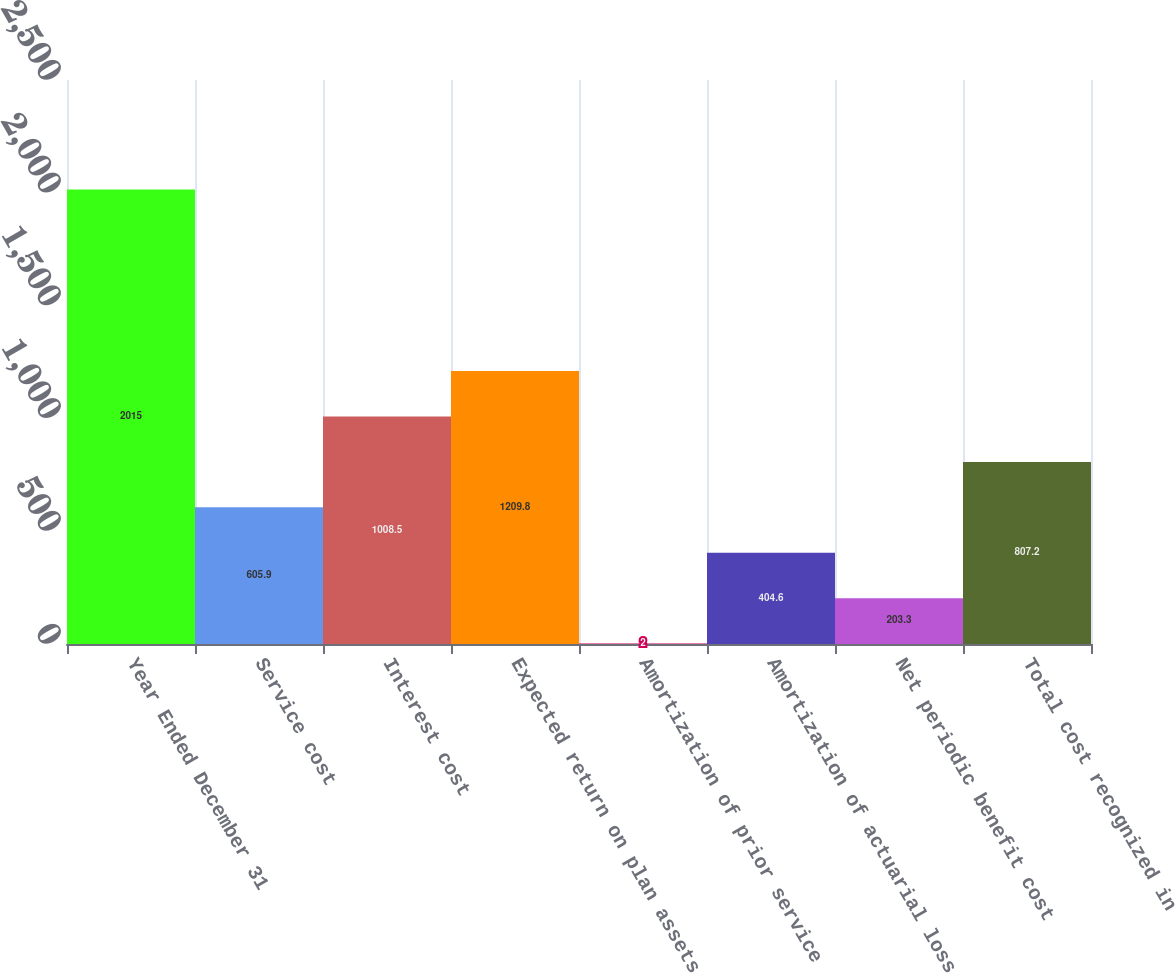<chart> <loc_0><loc_0><loc_500><loc_500><bar_chart><fcel>Year Ended December 31<fcel>Service cost<fcel>Interest cost<fcel>Expected return on plan assets<fcel>Amortization of prior service<fcel>Amortization of actuarial loss<fcel>Net periodic benefit cost<fcel>Total cost recognized in<nl><fcel>2015<fcel>605.9<fcel>1008.5<fcel>1209.8<fcel>2<fcel>404.6<fcel>203.3<fcel>807.2<nl></chart> 